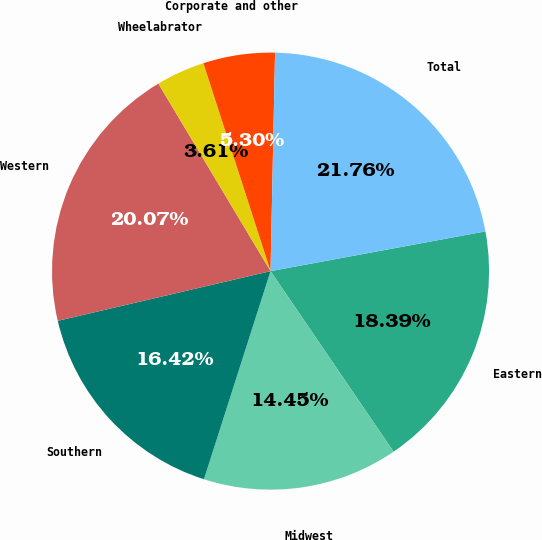Convert chart. <chart><loc_0><loc_0><loc_500><loc_500><pie_chart><fcel>Eastern<fcel>Midwest<fcel>Southern<fcel>Western<fcel>Wheelabrator<fcel>Corporate and other<fcel>Total<nl><fcel>18.39%<fcel>14.45%<fcel>16.42%<fcel>20.07%<fcel>3.61%<fcel>5.3%<fcel>21.76%<nl></chart> 